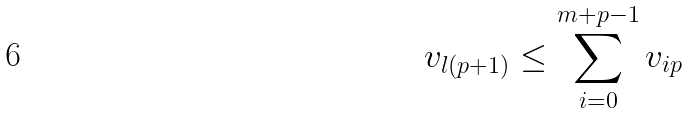<formula> <loc_0><loc_0><loc_500><loc_500>v _ { l ( p + 1 ) } \leq \sum _ { i = 0 } ^ { m + p - 1 } v _ { i p }</formula> 